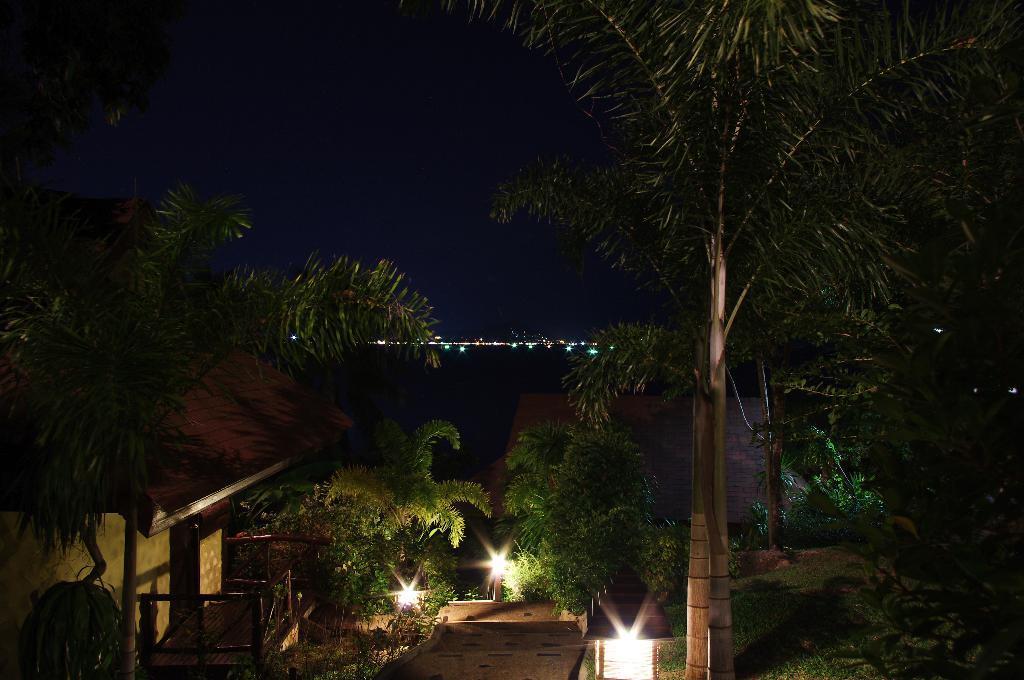Please provide a concise description of this image. In the picture we can see the garden space with a path and on both the sides of the path we can see lights and plants and far away from it we can see water surface and far away from it we can see lights and the sky. 